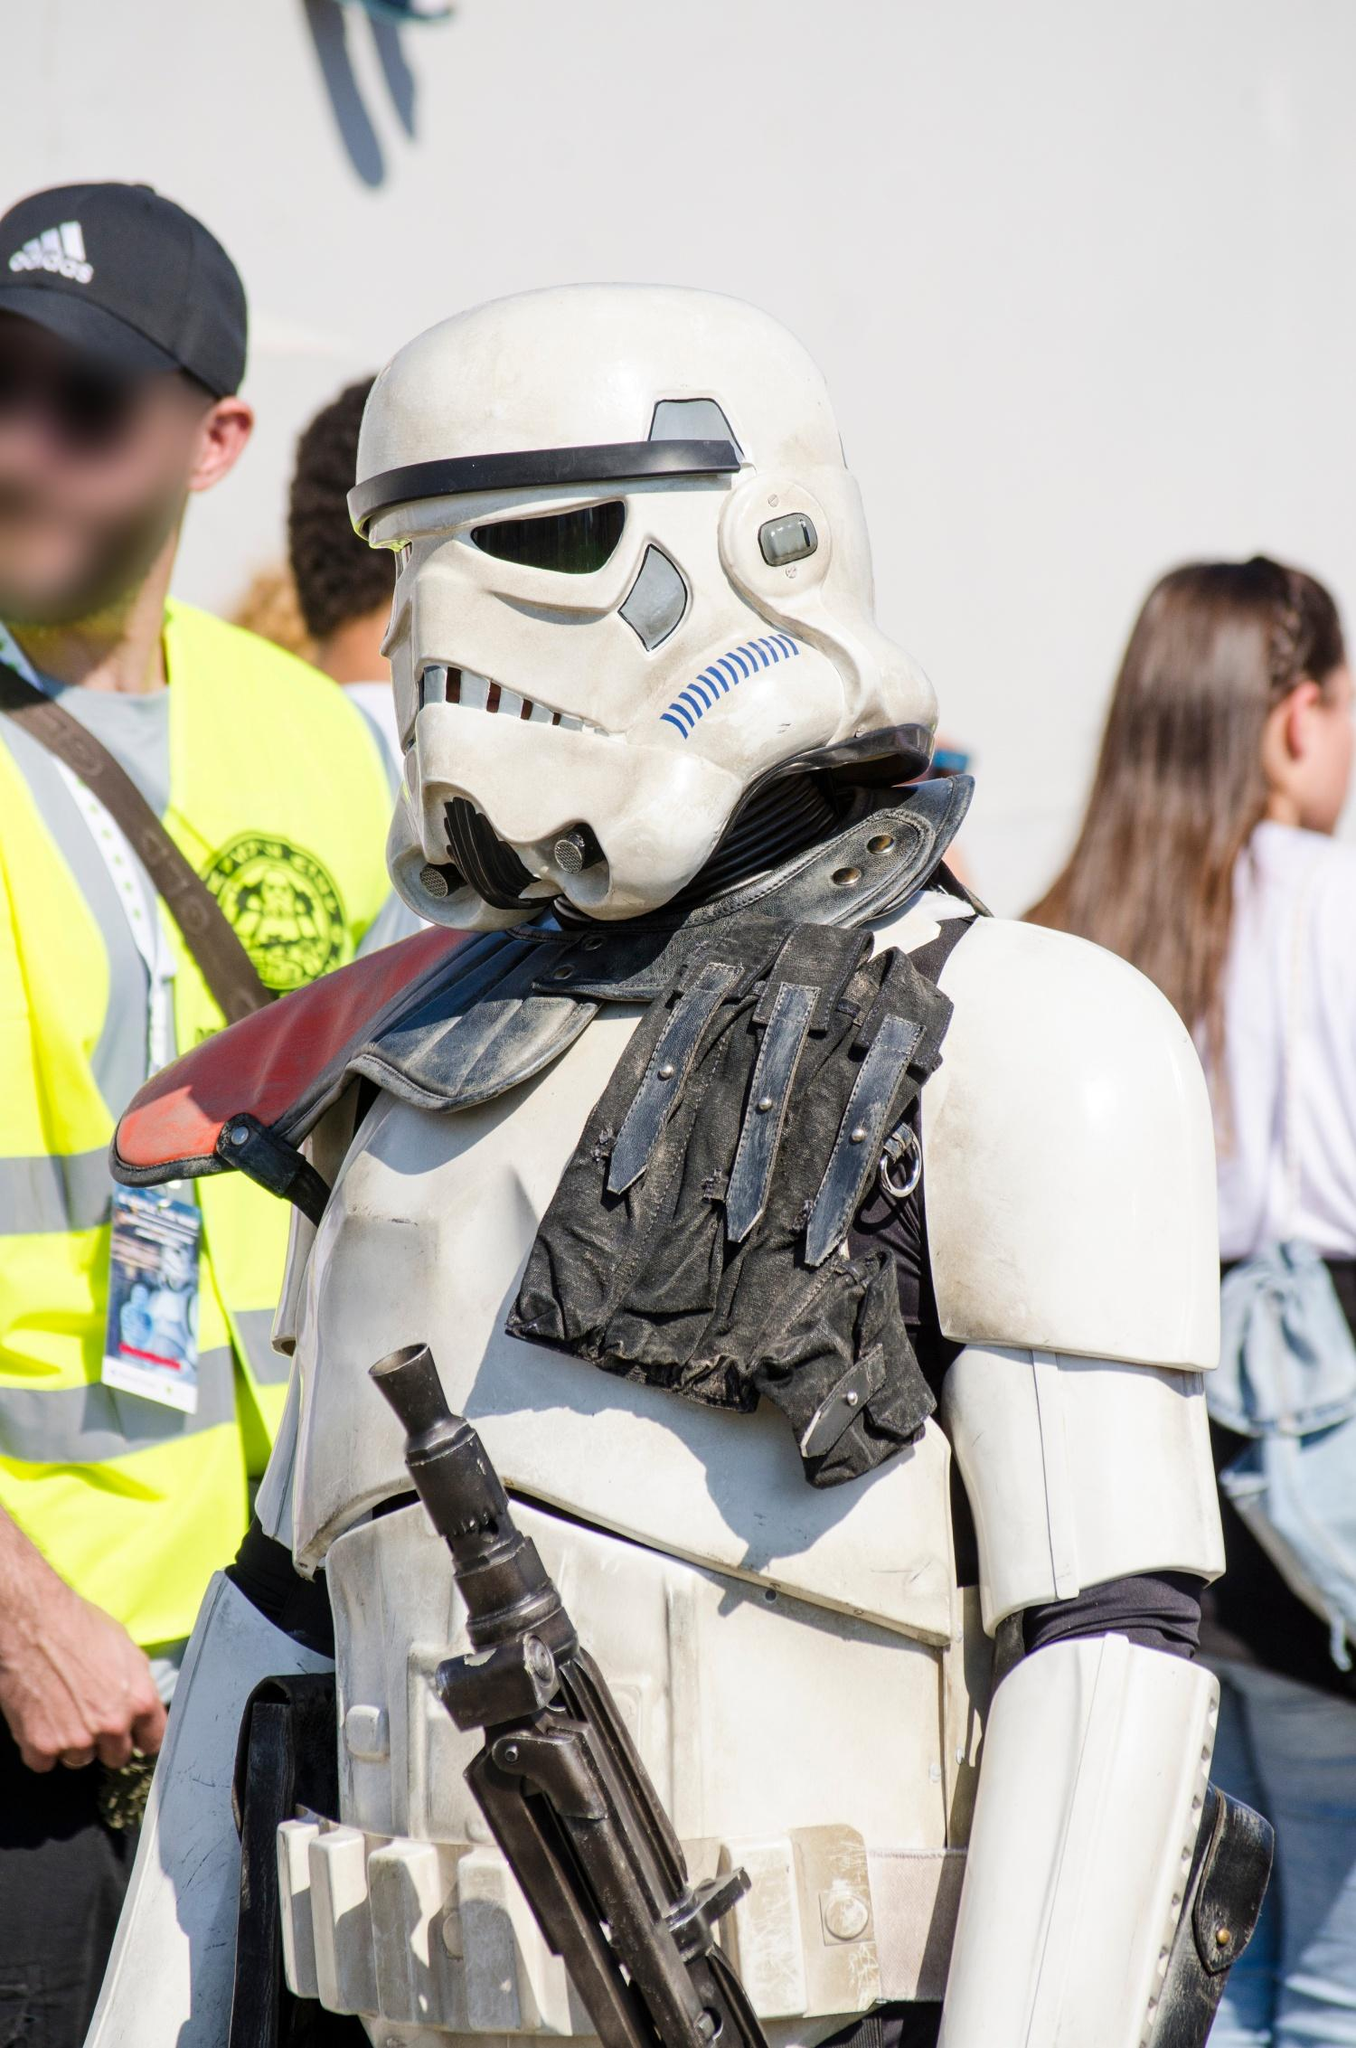Describe the material and construction of the costume in the image. The Stormtrooper costume appears to be constructed from durable plastic or fiberglass, which gives it a robust and authentic look. The armor pieces are intricately molded and painted to resemble the iconic design from the Star Wars films. The black undersuit that contrasts with the white armor is likely made from a stretchy, breathable fabric to allow for easy movement. The helmet, with its detailed ventilation and visor, suggests careful craftsmanship, likely involving a combination of casting and hand-painting. The weapon, a replica of a Stormtrooper blaster, appears to be made from plastic, painted to look like metal, adding to the overall authenticity of the costume. 